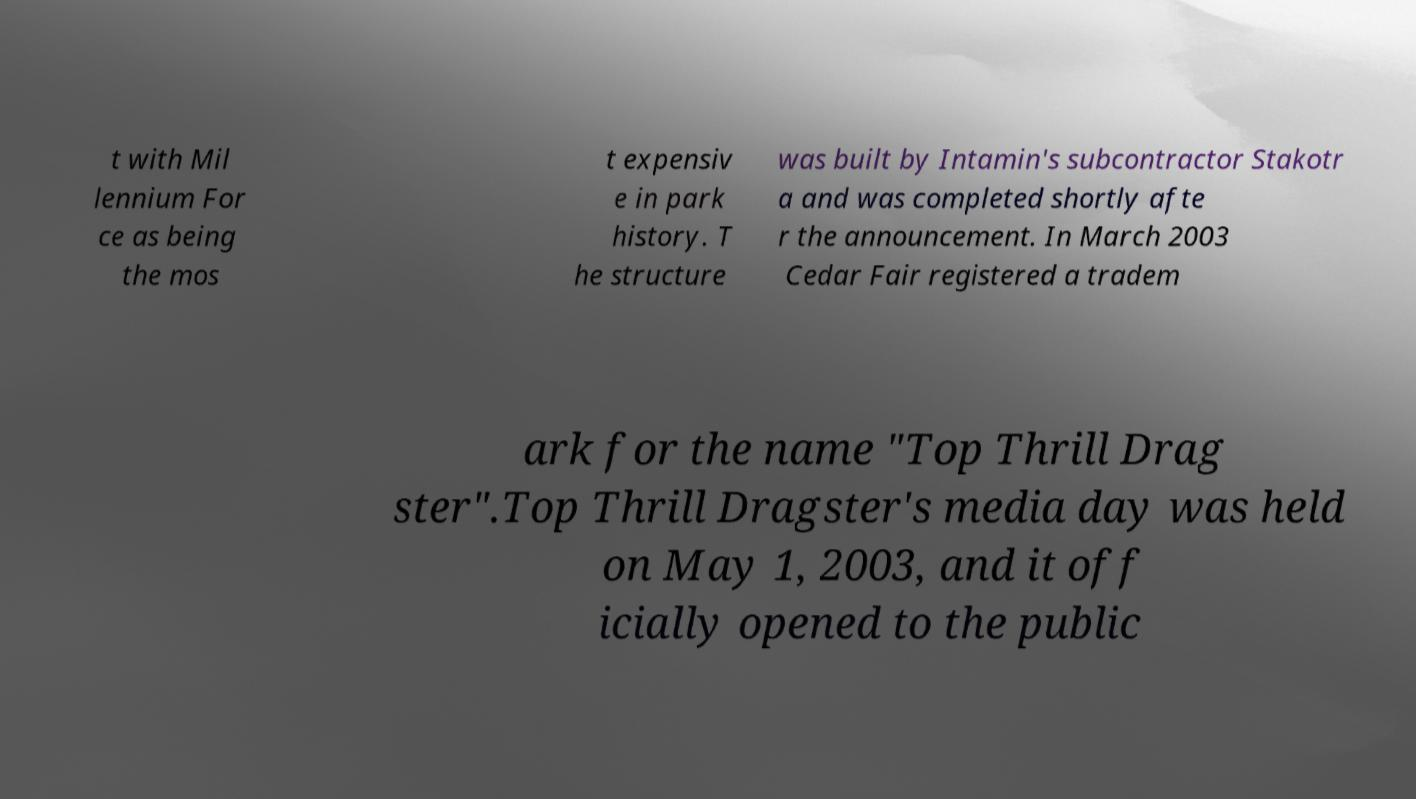Can you accurately transcribe the text from the provided image for me? t with Mil lennium For ce as being the mos t expensiv e in park history. T he structure was built by Intamin's subcontractor Stakotr a and was completed shortly afte r the announcement. In March 2003 Cedar Fair registered a tradem ark for the name "Top Thrill Drag ster".Top Thrill Dragster's media day was held on May 1, 2003, and it off icially opened to the public 